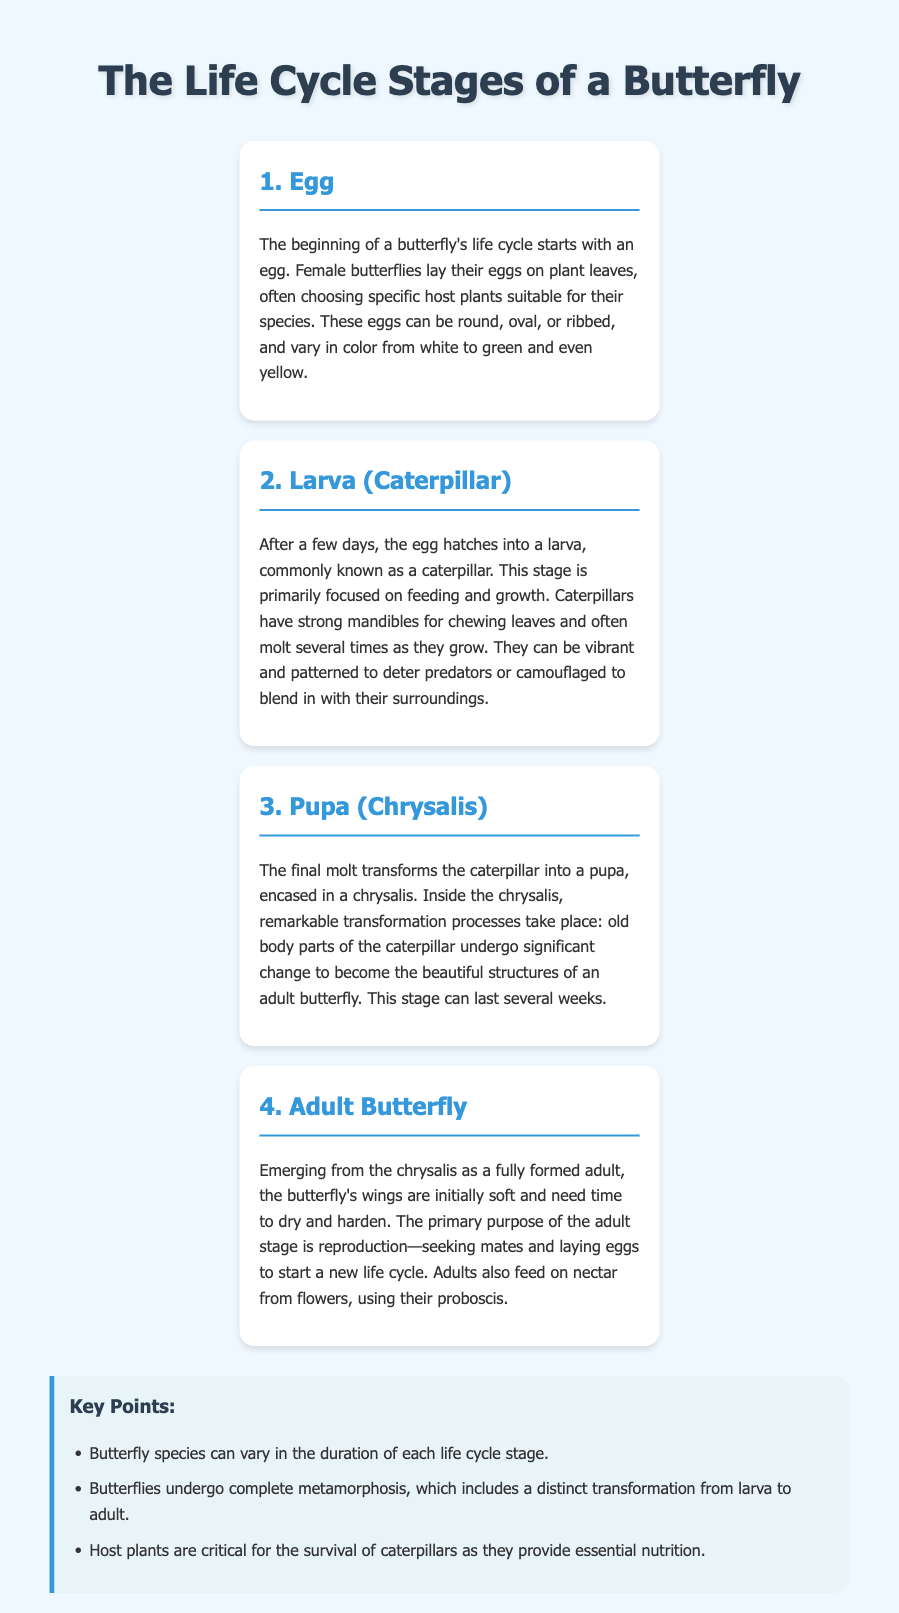What is the first stage of a butterfly's life cycle? The document states that the beginning of a butterfly's life cycle starts with an egg.
Answer: Egg What is the common name for the larva stage? In the document, the larva stage is commonly referred to as a caterpillar.
Answer: Caterpillar How many stages are there in the life cycle of a butterfly? The document outlines four distinct stages in the life cycle of a butterfly.
Answer: Four What is the main purpose of the adult butterfly stage? The document explains that the primary purpose of the adult stage is reproduction—seeking mates and laying eggs.
Answer: Reproduction What critical resource do caterpillars need for survival? According to the document, host plants are critical for the survival of caterpillars as they provide essential nutrition.
Answer: Host plants What is the appearance of butterfly eggs? The document notes that butterfly eggs can be round, oval, or ribbed, and vary in color from white to green and even yellow.
Answer: Round, oval, ribbed, white, green, yellow What happens during the pupa stage? The document states that significant transformation processes take place inside the chrysalis during the pupa stage.
Answer: Transformation processes How long can the pupa stage last? The document indicates that the pupa stage can last several weeks.
Answer: Several weeks 